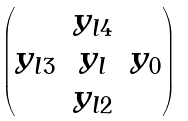<formula> <loc_0><loc_0><loc_500><loc_500>\begin{pmatrix} & y _ { l 4 } & \\ y _ { l 3 } & y _ { l } & y _ { 0 } \\ & y _ { l 2 } & \end{pmatrix}</formula> 